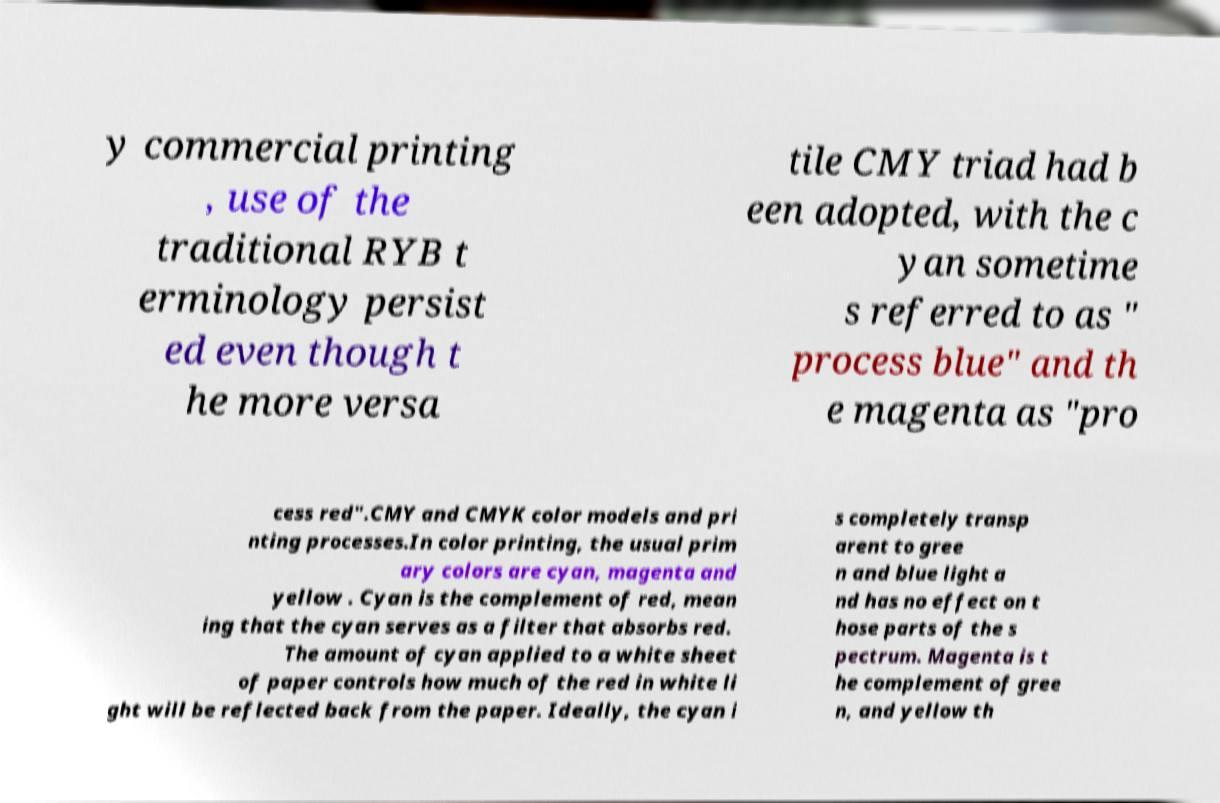Can you accurately transcribe the text from the provided image for me? y commercial printing , use of the traditional RYB t erminology persist ed even though t he more versa tile CMY triad had b een adopted, with the c yan sometime s referred to as " process blue" and th e magenta as "pro cess red".CMY and CMYK color models and pri nting processes.In color printing, the usual prim ary colors are cyan, magenta and yellow . Cyan is the complement of red, mean ing that the cyan serves as a filter that absorbs red. The amount of cyan applied to a white sheet of paper controls how much of the red in white li ght will be reflected back from the paper. Ideally, the cyan i s completely transp arent to gree n and blue light a nd has no effect on t hose parts of the s pectrum. Magenta is t he complement of gree n, and yellow th 